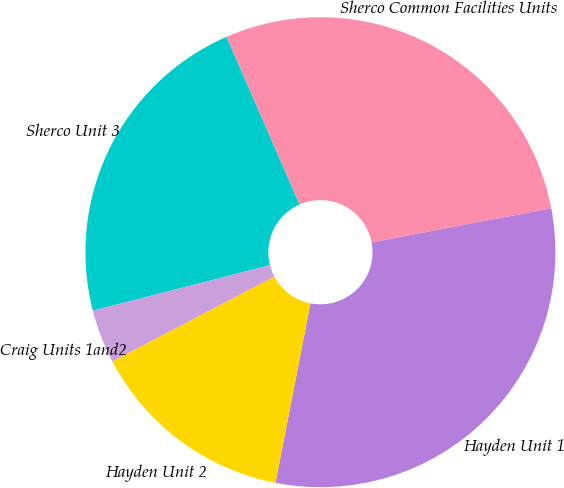Convert chart. <chart><loc_0><loc_0><loc_500><loc_500><pie_chart><fcel>Sherco Unit 3<fcel>Sherco Common Facilities Units<fcel>Hayden Unit 1<fcel>Hayden Unit 2<fcel>Craig Units 1and2<nl><fcel>22.46%<fcel>28.55%<fcel>31.06%<fcel>14.24%<fcel>3.69%<nl></chart> 